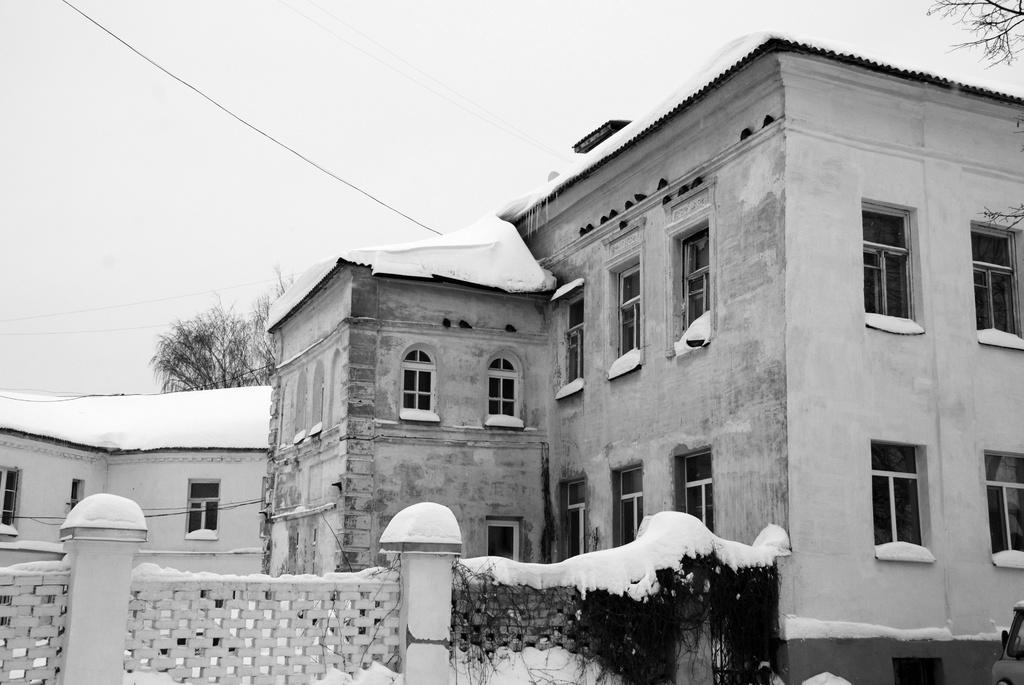What type of structures are located at the bottom of the image? There are buildings at the bottom of the image. What is covering the ground at the bottom of the image? There is snow at the bottom of the image. What can be seen in the background of the image? There are trees and wires in the background of the image. Can you see a dock in the image? There is no dock present in the image. What color is the tail of the animal in the image? There are no animals with tails present in the image. 